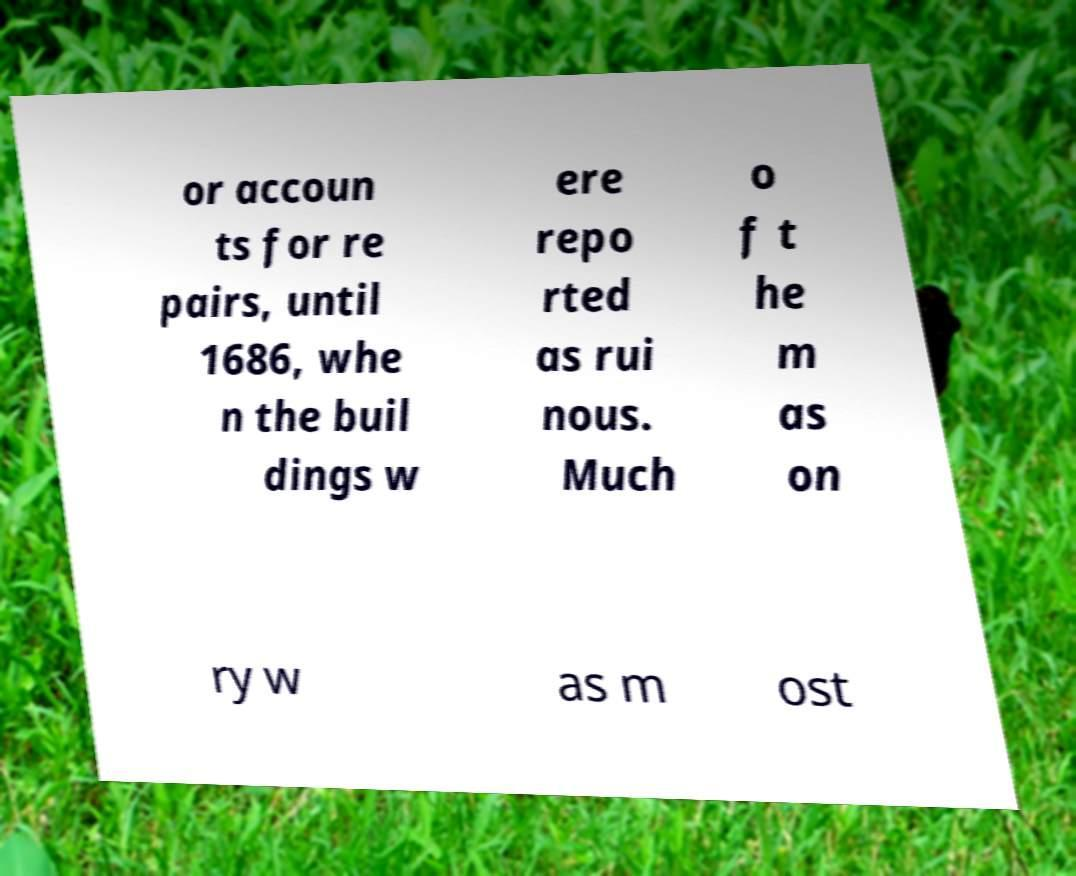What messages or text are displayed in this image? I need them in a readable, typed format. or accoun ts for re pairs, until 1686, whe n the buil dings w ere repo rted as rui nous. Much o f t he m as on ry w as m ost 